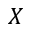<formula> <loc_0><loc_0><loc_500><loc_500>X</formula> 